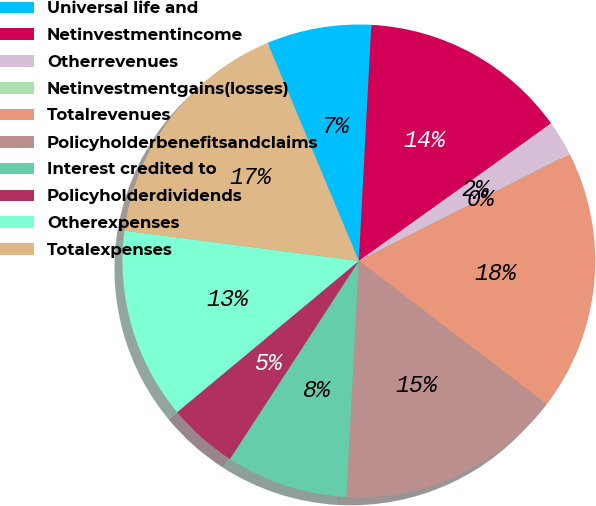Convert chart. <chart><loc_0><loc_0><loc_500><loc_500><pie_chart><fcel>Universal life and<fcel>Netinvestmentincome<fcel>Otherrevenues<fcel>Netinvestmentgains(losses)<fcel>Totalrevenues<fcel>Policyholderbenefitsandclaims<fcel>Interest credited to<fcel>Policyholderdividends<fcel>Otherexpenses<fcel>Totalexpenses<nl><fcel>7.15%<fcel>14.28%<fcel>2.4%<fcel>0.02%<fcel>17.84%<fcel>15.46%<fcel>8.34%<fcel>4.77%<fcel>13.09%<fcel>16.65%<nl></chart> 